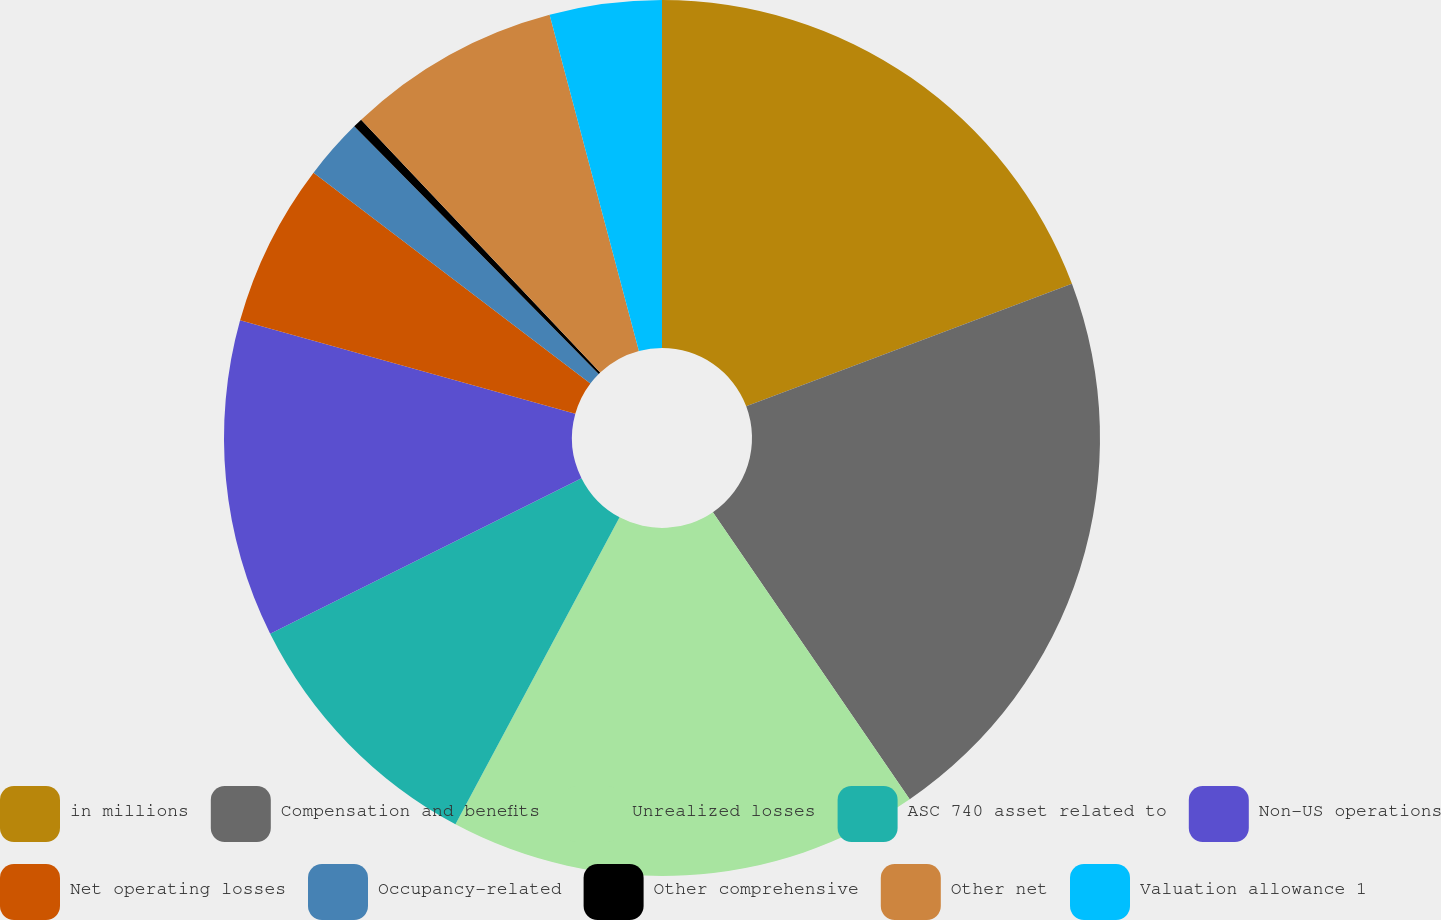Convert chart to OTSL. <chart><loc_0><loc_0><loc_500><loc_500><pie_chart><fcel>in millions<fcel>Compensation and benefits<fcel>Unrealized losses<fcel>ASC 740 asset related to<fcel>Non-US operations<fcel>Net operating losses<fcel>Occupancy-related<fcel>Other comprehensive<fcel>Other net<fcel>Valuation allowance 1<nl><fcel>19.27%<fcel>21.16%<fcel>17.38%<fcel>9.81%<fcel>11.7%<fcel>6.03%<fcel>2.24%<fcel>0.35%<fcel>7.92%<fcel>4.13%<nl></chart> 